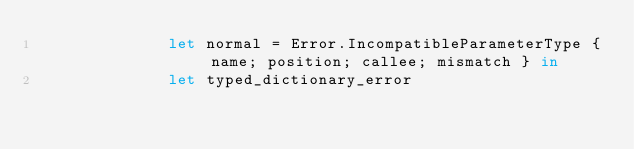Convert code to text. <code><loc_0><loc_0><loc_500><loc_500><_OCaml_>              let normal = Error.IncompatibleParameterType { name; position; callee; mismatch } in
              let typed_dictionary_error</code> 